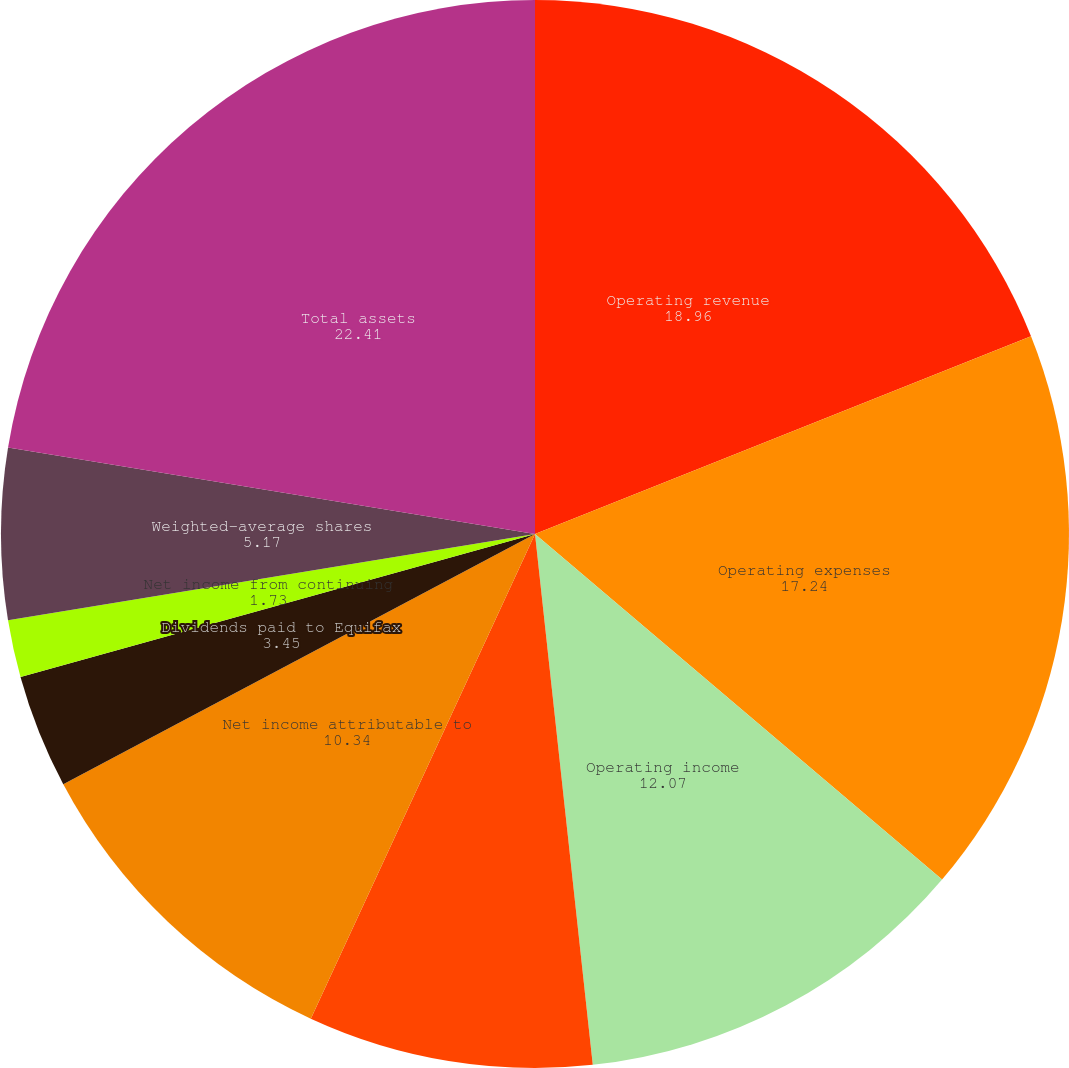<chart> <loc_0><loc_0><loc_500><loc_500><pie_chart><fcel>Operating revenue<fcel>Operating expenses<fcel>Operating income<fcel>Consolidated income from<fcel>Net income attributable to<fcel>Dividends paid to Equifax<fcel>Net income from continuing<fcel>Cash dividends declared per<fcel>Weighted-average shares<fcel>Total assets<nl><fcel>18.96%<fcel>17.24%<fcel>12.07%<fcel>8.62%<fcel>10.34%<fcel>3.45%<fcel>1.73%<fcel>0.0%<fcel>5.17%<fcel>22.41%<nl></chart> 